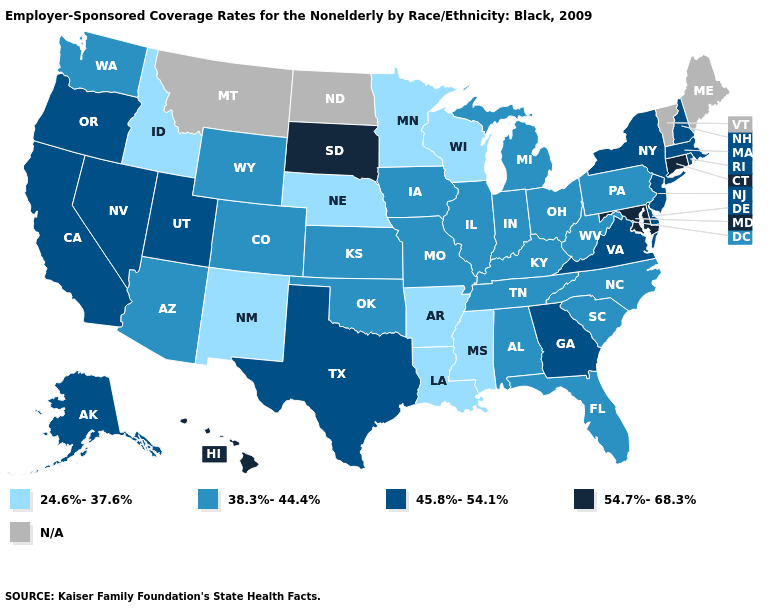What is the value of Washington?
Be succinct. 38.3%-44.4%. Among the states that border Montana , does Wyoming have the highest value?
Write a very short answer. No. What is the value of Massachusetts?
Answer briefly. 45.8%-54.1%. Which states have the highest value in the USA?
Concise answer only. Connecticut, Hawaii, Maryland, South Dakota. Which states hav the highest value in the Northeast?
Give a very brief answer. Connecticut. Does Tennessee have the lowest value in the USA?
Keep it brief. No. Does South Dakota have the highest value in the USA?
Be succinct. Yes. Which states have the highest value in the USA?
Short answer required. Connecticut, Hawaii, Maryland, South Dakota. Which states hav the highest value in the Northeast?
Answer briefly. Connecticut. Among the states that border Montana , does South Dakota have the highest value?
Be succinct. Yes. Name the states that have a value in the range N/A?
Be succinct. Maine, Montana, North Dakota, Vermont. Does the first symbol in the legend represent the smallest category?
Keep it brief. Yes. How many symbols are there in the legend?
Be succinct. 5. 